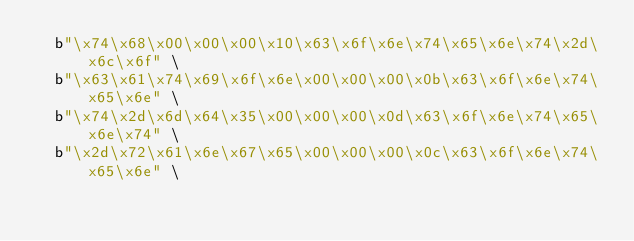Convert code to text. <code><loc_0><loc_0><loc_500><loc_500><_Cython_>	b"\x74\x68\x00\x00\x00\x10\x63\x6f\x6e\x74\x65\x6e\x74\x2d\x6c\x6f" \
	b"\x63\x61\x74\x69\x6f\x6e\x00\x00\x00\x0b\x63\x6f\x6e\x74\x65\x6e" \
	b"\x74\x2d\x6d\x64\x35\x00\x00\x00\x0d\x63\x6f\x6e\x74\x65\x6e\x74" \
	b"\x2d\x72\x61\x6e\x67\x65\x00\x00\x00\x0c\x63\x6f\x6e\x74\x65\x6e" \</code> 